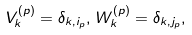Convert formula to latex. <formula><loc_0><loc_0><loc_500><loc_500>V _ { k } ^ { \left ( p \right ) } = \delta _ { k , i _ { p } } , \, W _ { k } ^ { \left ( p \right ) } = \delta _ { k , j _ { p } } ,</formula> 